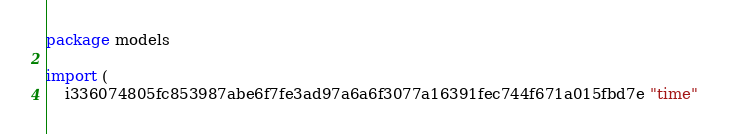<code> <loc_0><loc_0><loc_500><loc_500><_Go_>package models

import (
    i336074805fc853987abe6f7fe3ad97a6a6f3077a16391fec744f671a015fbd7e "time"</code> 